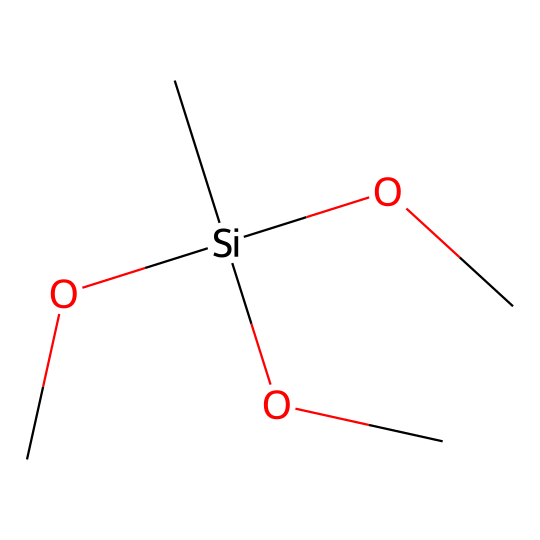What is the core atom of this silane? The core atom of silanes is silicon, which is represented by the 'Si' in the SMILES notation. It is the central atom to which other groups are attached.
Answer: silicon How many alkoxy groups are present in this structure? The structure contains three 'OC' groups, which are alkoxy groups. Each 'OC' represents an alkoxy group attached to the silicon atom.
Answer: three What is the hybridization of the silicon atom in this silane? The silicon atom is bonded to four groups, indicating it has a tetrahedral geometry, which corresponds to sp3 hybridization.
Answer: sp3 What type of compound is represented by this chemical structure? The structure represents a silane, characterized by the silicon atom bonded to organic groups and/or hydrogen. This is evident from the presence of a silicon atom (Si) central to the structure.
Answer: silane Does this silane have any hydrogen atoms attached? There are no hydrogen atoms in the provided structure, as the silicon atom is bonded only to alkoxy groups, indicating a fully substituted silane without hydrogens.
Answer: no What role do the alkoxy groups play in the preservation of thatched roofs? Alkoxy groups enhance hydrophobic properties, which prevents moisture damage and degradation in traditional thatched roofs. This helps in preserving the material and extending its lifespan.
Answer: hydrophobic What is the total number of atoms in the silane molecule? Counting the atoms gives: 1 silicon (Si), 3 carbons (C), and 9 oxygens (O) from the 3 'OC' groups, totaling 13 atoms.
Answer: thirteen 